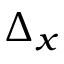<formula> <loc_0><loc_0><loc_500><loc_500>\Delta _ { x }</formula> 